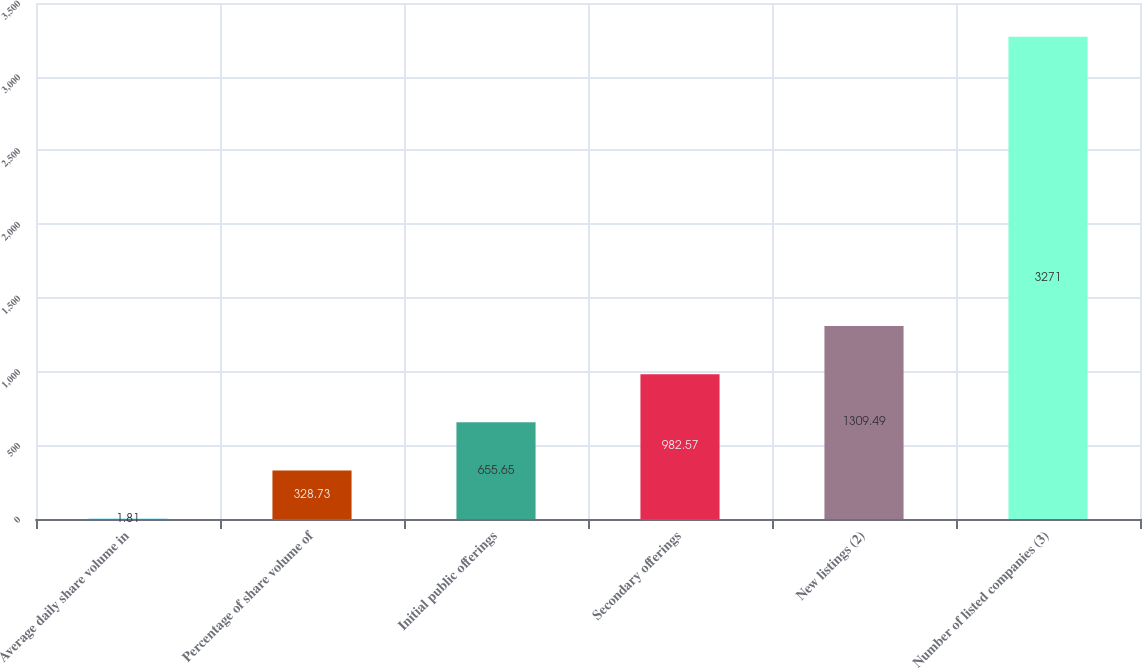Convert chart. <chart><loc_0><loc_0><loc_500><loc_500><bar_chart><fcel>Average daily share volume in<fcel>Percentage of share volume of<fcel>Initial public offerings<fcel>Secondary offerings<fcel>New listings (2)<fcel>Number of listed companies (3)<nl><fcel>1.81<fcel>328.73<fcel>655.65<fcel>982.57<fcel>1309.49<fcel>3271<nl></chart> 